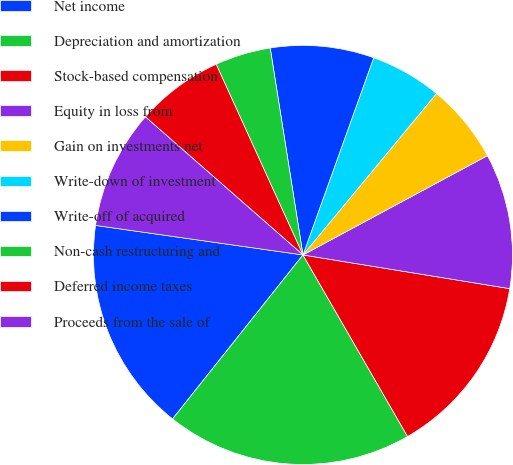Convert chart to OTSL. <chart><loc_0><loc_0><loc_500><loc_500><pie_chart><fcel>Net income<fcel>Depreciation and amortization<fcel>Stock-based compensation<fcel>Equity in loss from<fcel>Gain on investments net<fcel>Write-down of investment<fcel>Write-off of acquired<fcel>Non-cash restructuring and<fcel>Deferred income taxes<fcel>Proceeds from the sale of<nl><fcel>16.56%<fcel>19.01%<fcel>14.11%<fcel>10.43%<fcel>6.14%<fcel>5.52%<fcel>7.98%<fcel>4.3%<fcel>6.75%<fcel>9.2%<nl></chart> 